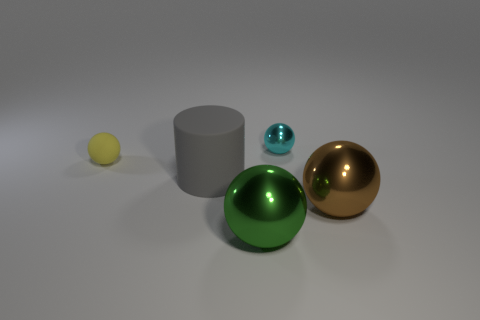Is the shape of the cyan metal thing the same as the big metallic object that is to the right of the tiny cyan shiny object?
Ensure brevity in your answer.  Yes. The green object that is the same shape as the big brown metal object is what size?
Provide a short and direct response. Large. How many other objects are the same size as the cyan object?
Your response must be concise. 1. What shape is the large shiny object right of the tiny ball to the right of the large metallic thing left of the big brown metallic ball?
Your answer should be very brief. Sphere. Does the cyan metallic ball have the same size as the matte thing in front of the yellow object?
Keep it short and to the point. No. The sphere that is both behind the large gray matte cylinder and right of the large green object is what color?
Offer a very short reply. Cyan. How many other things are there of the same shape as the cyan metal thing?
Offer a terse response. 3. Do the metallic object right of the cyan shiny ball and the matte thing to the left of the gray cylinder have the same size?
Make the answer very short. No. There is a tiny thing in front of the ball that is behind the sphere that is left of the big gray cylinder; what is its material?
Offer a very short reply. Rubber. Does the green object have the same shape as the big gray object?
Your response must be concise. No. 